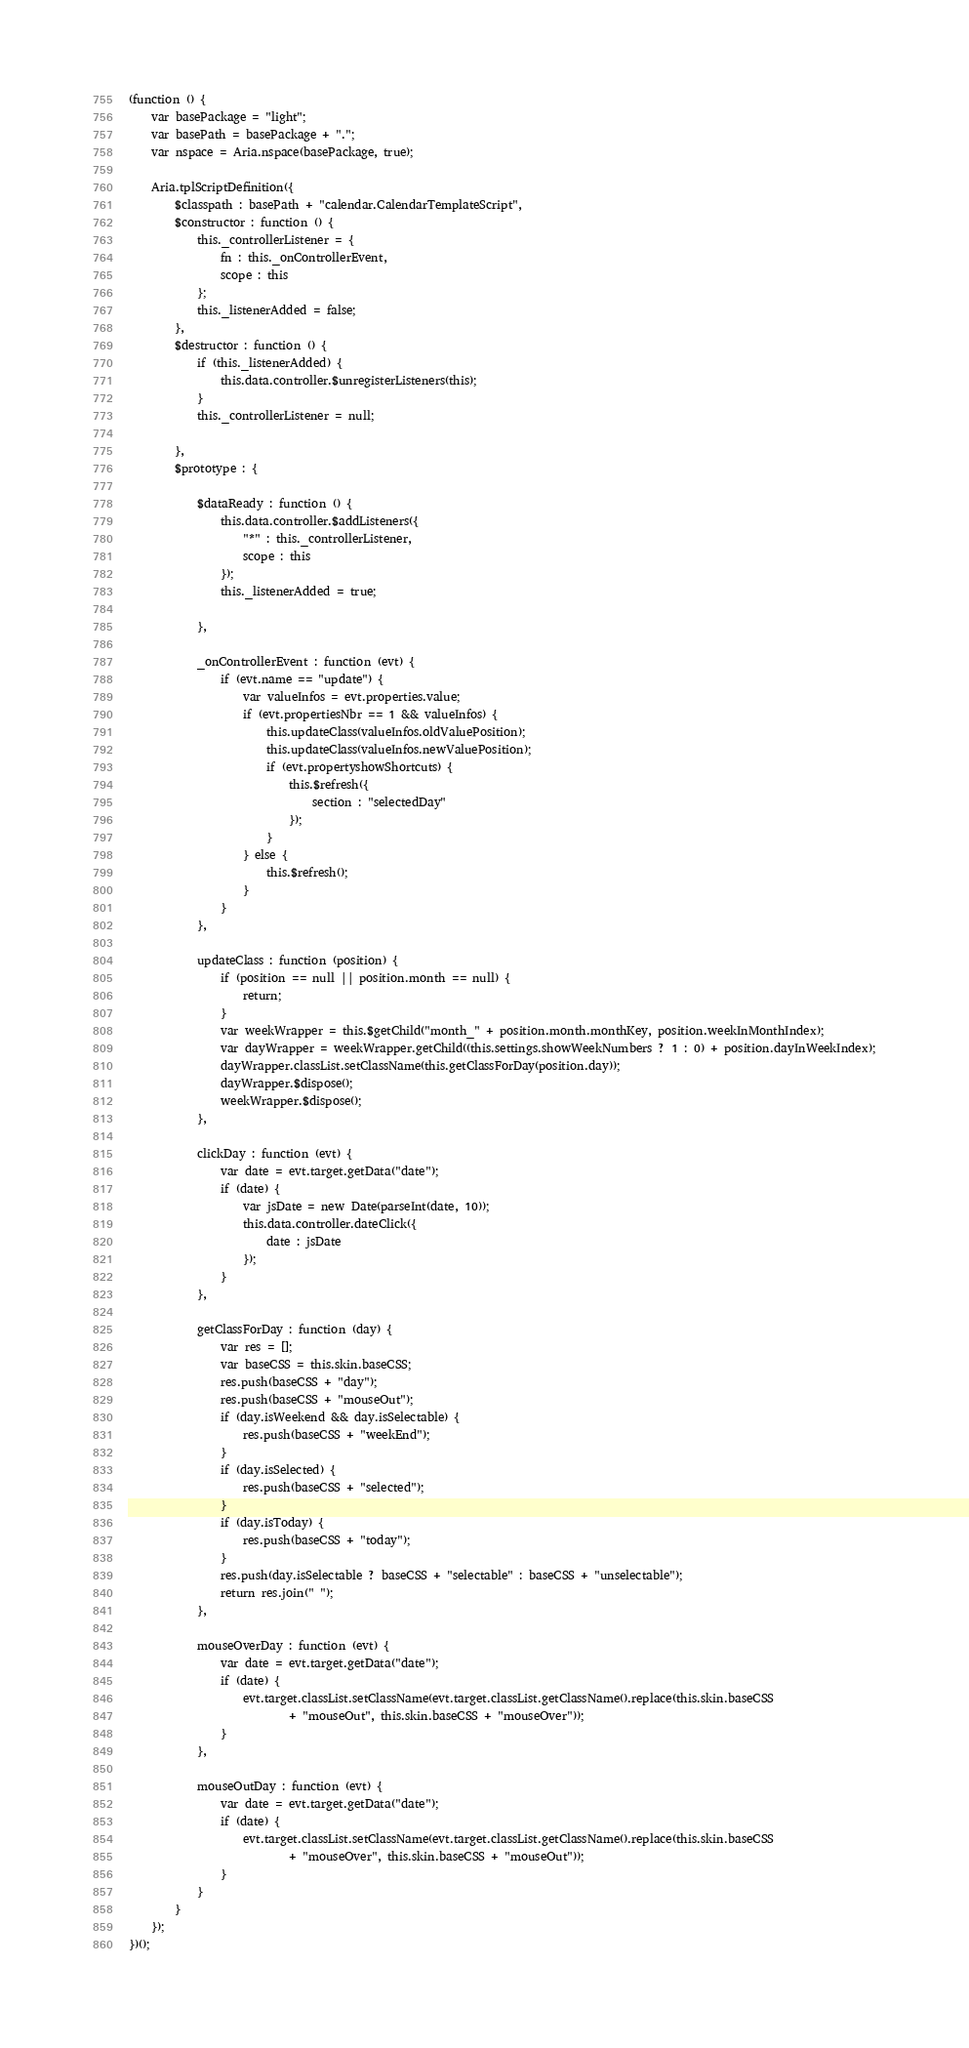<code> <loc_0><loc_0><loc_500><loc_500><_JavaScript_>(function () {
    var basePackage = "light";
    var basePath = basePackage + ".";
    var nspace = Aria.nspace(basePackage, true);

    Aria.tplScriptDefinition({
        $classpath : basePath + "calendar.CalendarTemplateScript",
        $constructor : function () {
            this._controllerListener = {
                fn : this._onControllerEvent,
                scope : this
            };
            this._listenerAdded = false;
        },
        $destructor : function () {
            if (this._listenerAdded) {
                this.data.controller.$unregisterListeners(this);
            }
            this._controllerListener = null;

        },
        $prototype : {

            $dataReady : function () {
                this.data.controller.$addListeners({
                    "*" : this._controllerListener,
                    scope : this
                });
                this._listenerAdded = true;

            },

            _onControllerEvent : function (evt) {
                if (evt.name == "update") {
                    var valueInfos = evt.properties.value;
                    if (evt.propertiesNbr == 1 && valueInfos) {
                        this.updateClass(valueInfos.oldValuePosition);
                        this.updateClass(valueInfos.newValuePosition);
                        if (evt.propertyshowShortcuts) {
                            this.$refresh({
                                section : "selectedDay"
                            });
                        }
                    } else {
                        this.$refresh();
                    }
                }
            },

            updateClass : function (position) {
                if (position == null || position.month == null) {
                    return;
                }
                var weekWrapper = this.$getChild("month_" + position.month.monthKey, position.weekInMonthIndex);
                var dayWrapper = weekWrapper.getChild((this.settings.showWeekNumbers ? 1 : 0) + position.dayInWeekIndex);
                dayWrapper.classList.setClassName(this.getClassForDay(position.day));
                dayWrapper.$dispose();
                weekWrapper.$dispose();
            },

            clickDay : function (evt) {
                var date = evt.target.getData("date");
                if (date) {
                    var jsDate = new Date(parseInt(date, 10));
                    this.data.controller.dateClick({
                        date : jsDate
                    });
                }
            },

            getClassForDay : function (day) {
                var res = [];
                var baseCSS = this.skin.baseCSS;
                res.push(baseCSS + "day");
                res.push(baseCSS + "mouseOut");
                if (day.isWeekend && day.isSelectable) {
                    res.push(baseCSS + "weekEnd");
                }
                if (day.isSelected) {
                    res.push(baseCSS + "selected");
                }
                if (day.isToday) {
                    res.push(baseCSS + "today");
                }
                res.push(day.isSelectable ? baseCSS + "selectable" : baseCSS + "unselectable");
                return res.join(" ");
            },

            mouseOverDay : function (evt) {
                var date = evt.target.getData("date");
                if (date) {
                    evt.target.classList.setClassName(evt.target.classList.getClassName().replace(this.skin.baseCSS
                            + "mouseOut", this.skin.baseCSS + "mouseOver"));
                }
            },

            mouseOutDay : function (evt) {
                var date = evt.target.getData("date");
                if (date) {
                    evt.target.classList.setClassName(evt.target.classList.getClassName().replace(this.skin.baseCSS
                            + "mouseOver", this.skin.baseCSS + "mouseOut"));
                }
            }
        }
    });
})();</code> 